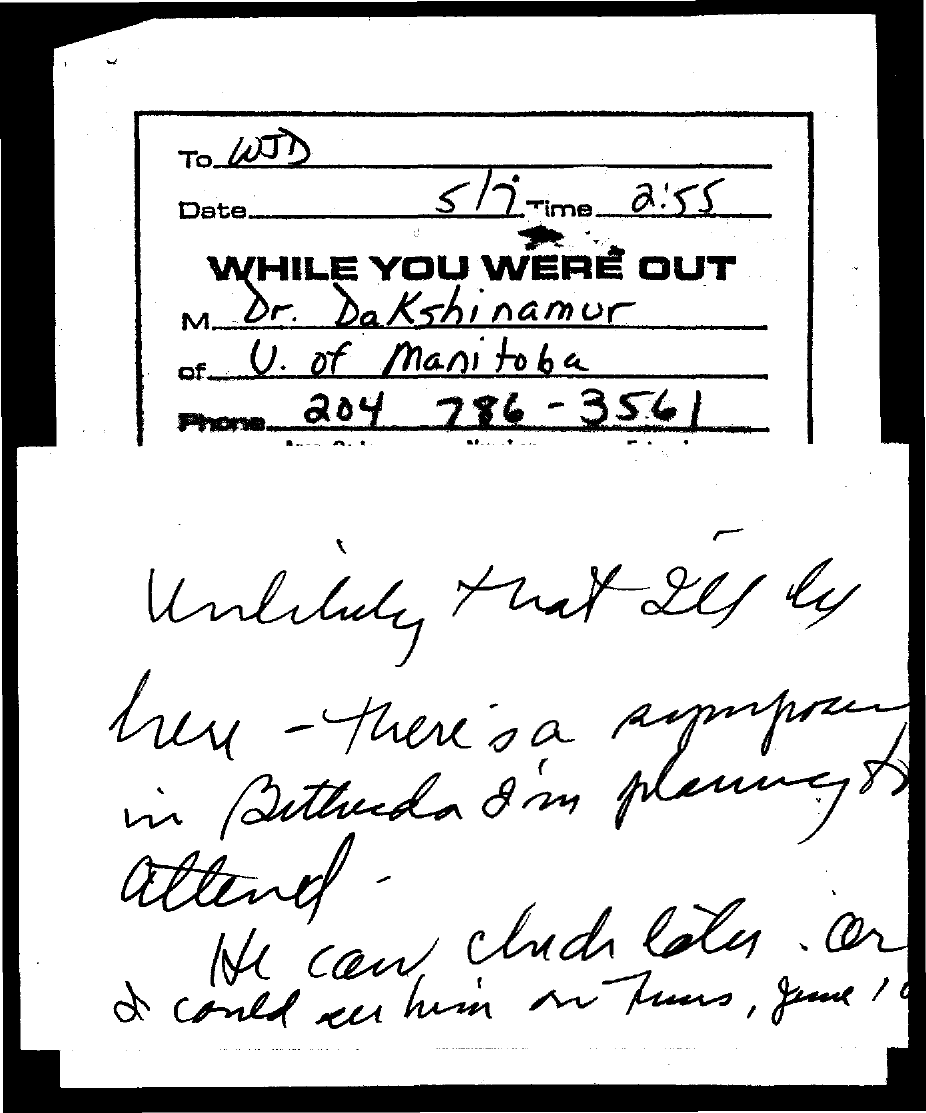To Whom is this letter addressed to?
Provide a succinct answer. WJD. What is the date on the document?
Your answer should be compact. 5/7. What is the Time?
Make the answer very short. 2:55. Who is this letter from?
Provide a succinct answer. Dr. Dakshinamur. Where is he from?
Your answer should be very brief. U. of Manitoba. What is the Phone?
Keep it short and to the point. 204 786 - 3561. 